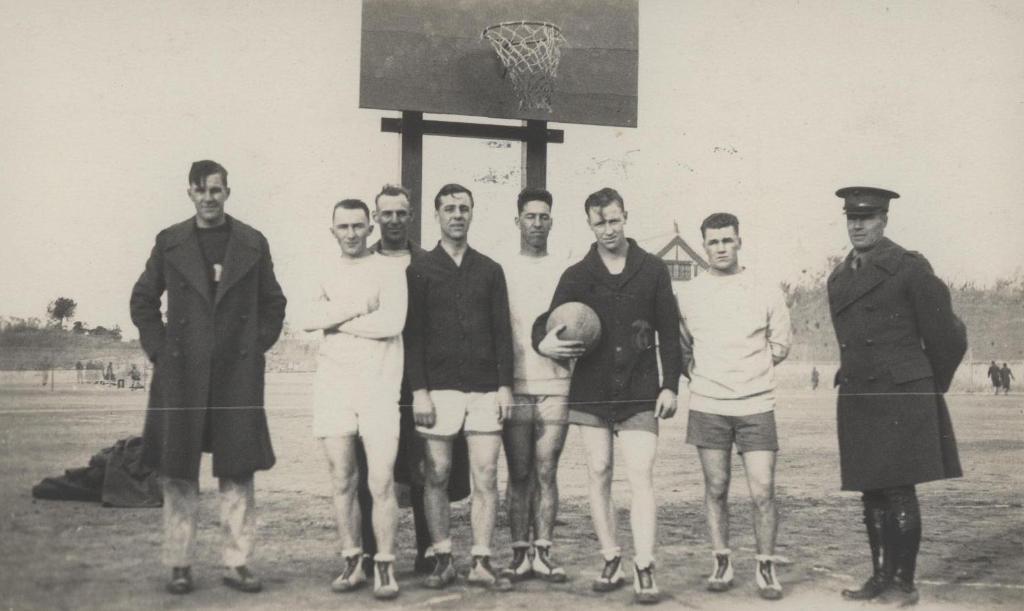Can you describe this image briefly? In this image we can see some people standing on the ground, a person holding a ball, a cover on the ground, a stand and a basketball hoop. On the backside we can see a fence, people, trees and the sky. 